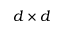Convert formula to latex. <formula><loc_0><loc_0><loc_500><loc_500>d \times d</formula> 